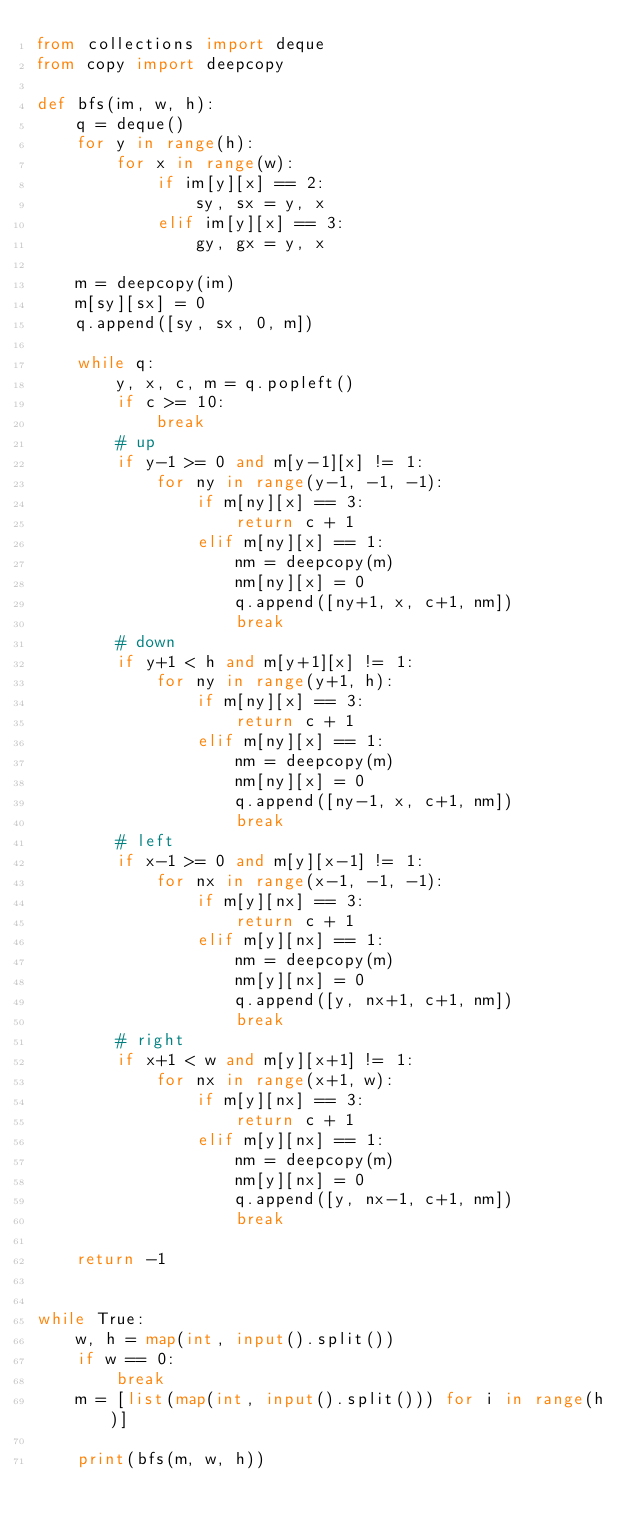<code> <loc_0><loc_0><loc_500><loc_500><_Python_>from collections import deque
from copy import deepcopy

def bfs(im, w, h):
    q = deque()
    for y in range(h):
        for x in range(w):
            if im[y][x] == 2:
                sy, sx = y, x
            elif im[y][x] == 3:
                gy, gx = y, x

    m = deepcopy(im)
    m[sy][sx] = 0
    q.append([sy, sx, 0, m])

    while q:
        y, x, c, m = q.popleft()
        if c >= 10:
            break
        # up
        if y-1 >= 0 and m[y-1][x] != 1:
            for ny in range(y-1, -1, -1):
                if m[ny][x] == 3:
                    return c + 1
                elif m[ny][x] == 1:
                    nm = deepcopy(m)
                    nm[ny][x] = 0
                    q.append([ny+1, x, c+1, nm])
                    break
        # down
        if y+1 < h and m[y+1][x] != 1:
            for ny in range(y+1, h):
                if m[ny][x] == 3:
                    return c + 1
                elif m[ny][x] == 1:
                    nm = deepcopy(m)
                    nm[ny][x] = 0
                    q.append([ny-1, x, c+1, nm])
                    break
        # left
        if x-1 >= 0 and m[y][x-1] != 1:
            for nx in range(x-1, -1, -1):
                if m[y][nx] == 3:
                    return c + 1
                elif m[y][nx] == 1:
                    nm = deepcopy(m)
                    nm[y][nx] = 0
                    q.append([y, nx+1, c+1, nm])
                    break
        # right
        if x+1 < w and m[y][x+1] != 1:
            for nx in range(x+1, w):
                if m[y][nx] == 3:
                    return c + 1
                elif m[y][nx] == 1:
                    nm = deepcopy(m)
                    nm[y][nx] = 0
                    q.append([y, nx-1, c+1, nm])
                    break

    return -1


while True:
    w, h = map(int, input().split())
    if w == 0:
        break
    m = [list(map(int, input().split())) for i in range(h)]
    
    print(bfs(m, w, h))</code> 